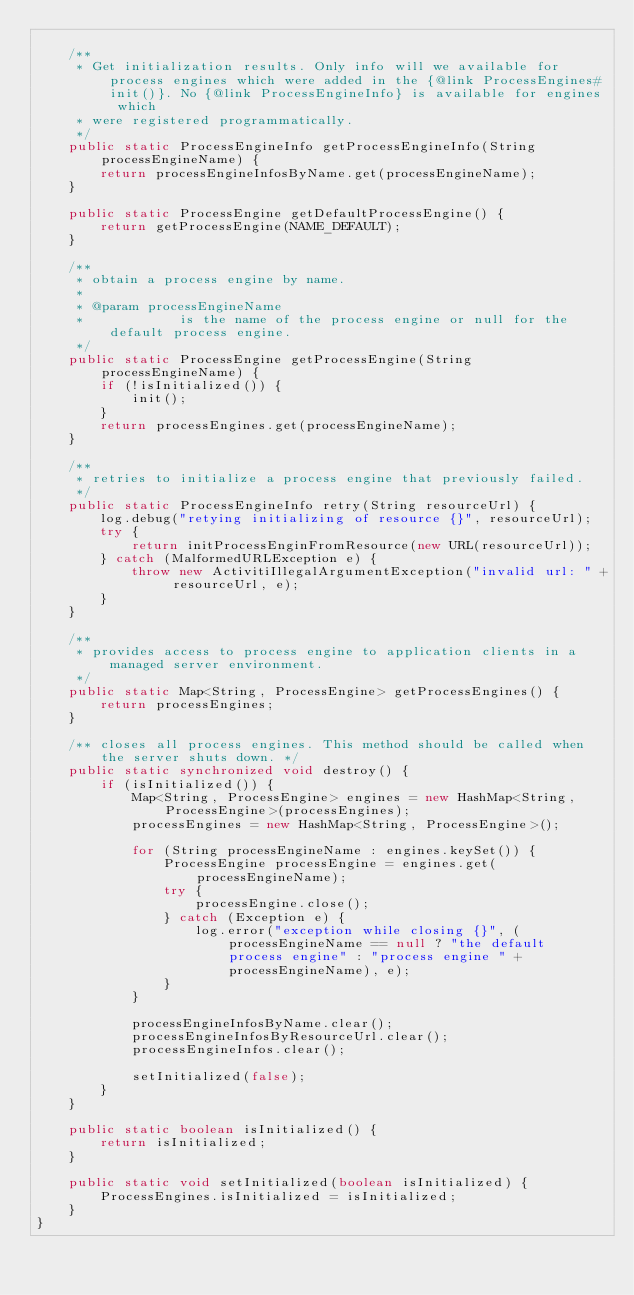Convert code to text. <code><loc_0><loc_0><loc_500><loc_500><_Java_>
    /**
     * Get initialization results. Only info will we available for process engines which were added in the {@link ProcessEngines#init()}. No {@link ProcessEngineInfo} is available for engines which
     * were registered programmatically.
     */
    public static ProcessEngineInfo getProcessEngineInfo(String processEngineName) {
        return processEngineInfosByName.get(processEngineName);
    }

    public static ProcessEngine getDefaultProcessEngine() {
        return getProcessEngine(NAME_DEFAULT);
    }

    /**
     * obtain a process engine by name.
     * 
     * @param processEngineName
     *            is the name of the process engine or null for the default process engine.
     */
    public static ProcessEngine getProcessEngine(String processEngineName) {
        if (!isInitialized()) {
            init();
        }
        return processEngines.get(processEngineName);
    }

    /**
     * retries to initialize a process engine that previously failed.
     */
    public static ProcessEngineInfo retry(String resourceUrl) {
        log.debug("retying initializing of resource {}", resourceUrl);
        try {
            return initProcessEnginFromResource(new URL(resourceUrl));
        } catch (MalformedURLException e) {
            throw new ActivitiIllegalArgumentException("invalid url: " + resourceUrl, e);
        }
    }

    /**
     * provides access to process engine to application clients in a managed server environment.
     */
    public static Map<String, ProcessEngine> getProcessEngines() {
        return processEngines;
    }

    /** closes all process engines. This method should be called when the server shuts down. */
    public static synchronized void destroy() {
        if (isInitialized()) {
            Map<String, ProcessEngine> engines = new HashMap<String, ProcessEngine>(processEngines);
            processEngines = new HashMap<String, ProcessEngine>();

            for (String processEngineName : engines.keySet()) {
                ProcessEngine processEngine = engines.get(processEngineName);
                try {
                    processEngine.close();
                } catch (Exception e) {
                    log.error("exception while closing {}", (processEngineName == null ? "the default process engine" : "process engine " + processEngineName), e);
                }
            }

            processEngineInfosByName.clear();
            processEngineInfosByResourceUrl.clear();
            processEngineInfos.clear();

            setInitialized(false);
        }
    }

    public static boolean isInitialized() {
        return isInitialized;
    }

    public static void setInitialized(boolean isInitialized) {
        ProcessEngines.isInitialized = isInitialized;
    }
}
</code> 